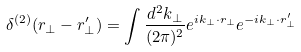Convert formula to latex. <formula><loc_0><loc_0><loc_500><loc_500>\delta ^ { ( 2 ) } ( { r } _ { \perp } - { r } _ { \perp } ^ { \prime } ) = \int \frac { d ^ { 2 } k _ { \perp } } { ( 2 \pi ) ^ { 2 } } e ^ { i { k } _ { \perp } \cdot { r } _ { \perp } } e ^ { - i { k } _ { \perp } \cdot { r } _ { \perp } ^ { \prime } }</formula> 